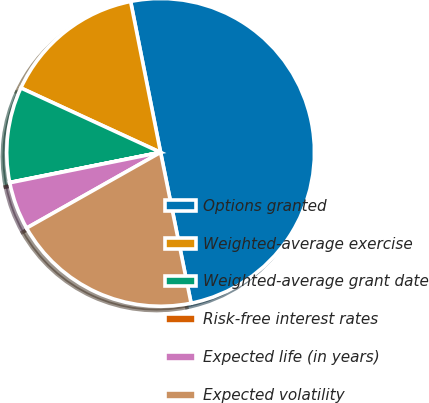<chart> <loc_0><loc_0><loc_500><loc_500><pie_chart><fcel>Options granted<fcel>Weighted-average exercise<fcel>Weighted-average grant date<fcel>Risk-free interest rates<fcel>Expected life (in years)<fcel>Expected volatility<nl><fcel>49.94%<fcel>15.0%<fcel>10.01%<fcel>0.03%<fcel>5.02%<fcel>19.99%<nl></chart> 